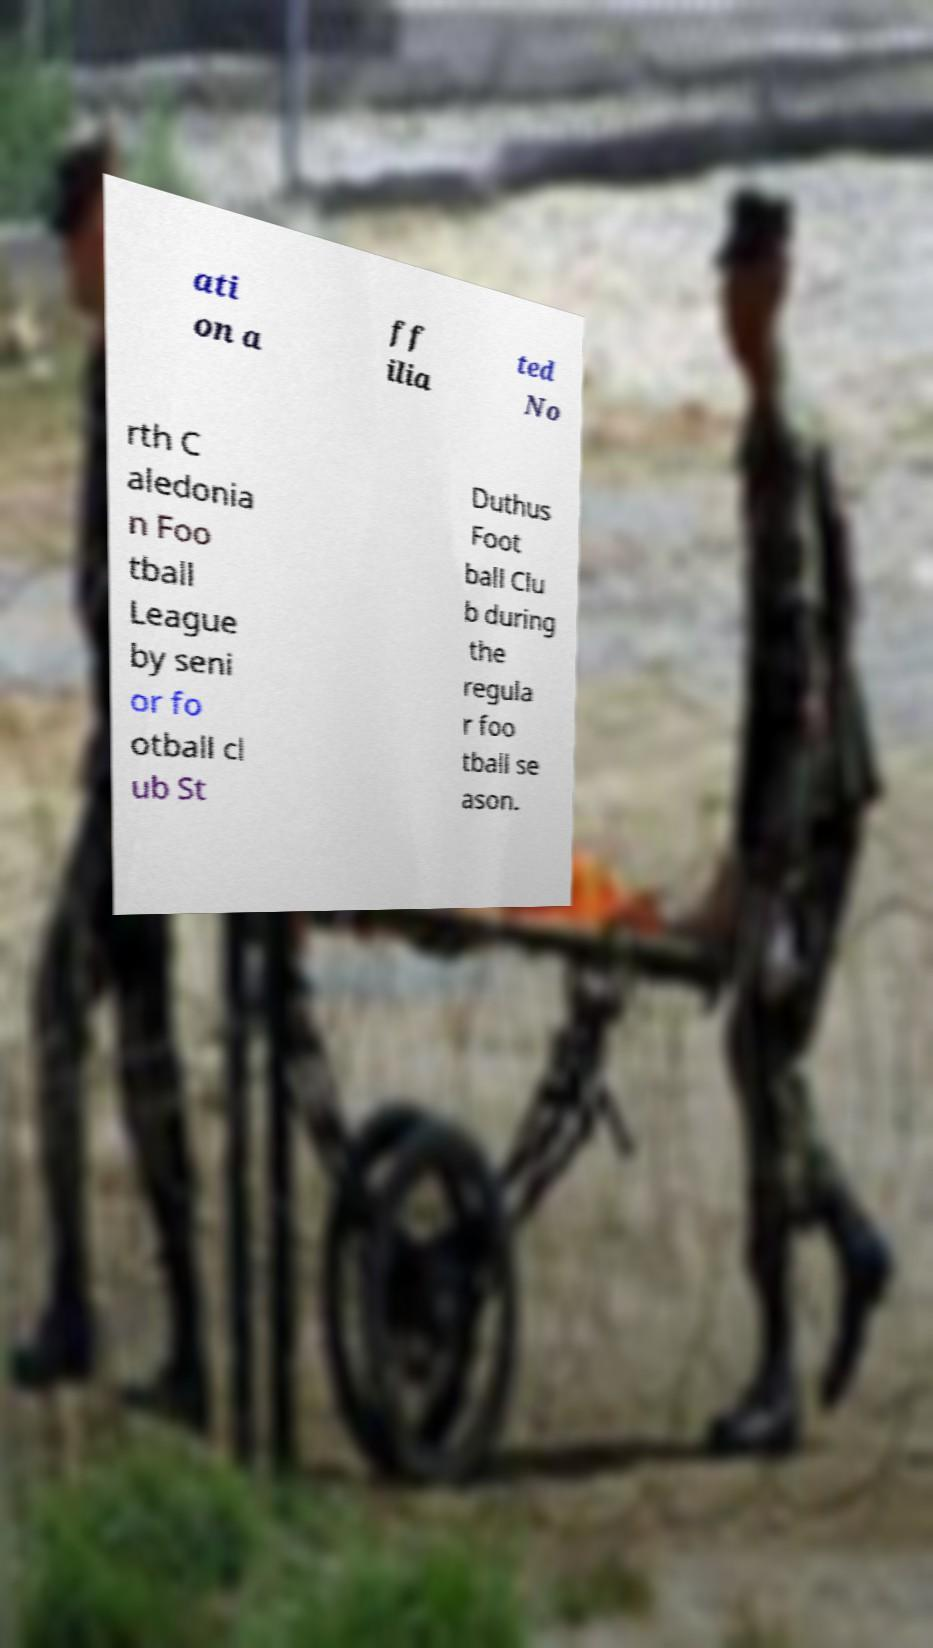I need the written content from this picture converted into text. Can you do that? ati on a ff ilia ted No rth C aledonia n Foo tball League by seni or fo otball cl ub St Duthus Foot ball Clu b during the regula r foo tball se ason. 